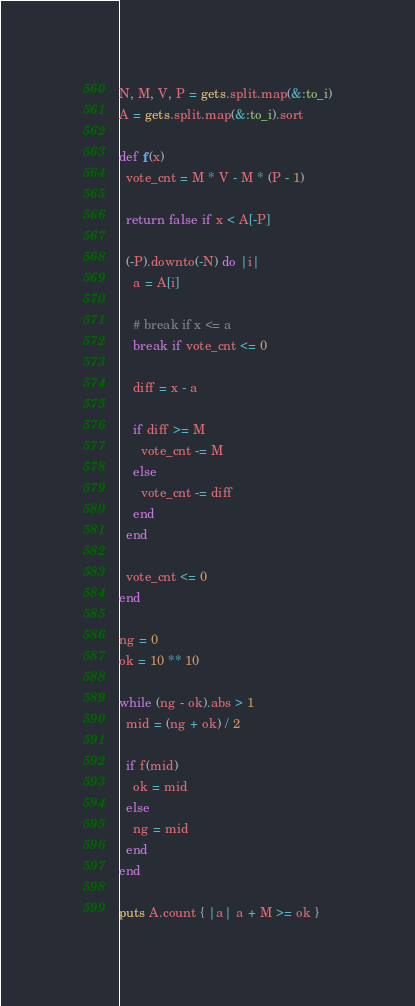<code> <loc_0><loc_0><loc_500><loc_500><_Ruby_>N, M, V, P = gets.split.map(&:to_i)
A = gets.split.map(&:to_i).sort

def f(x)
  vote_cnt = M * V - M * (P - 1)

  return false if x < A[-P]

  (-P).downto(-N) do |i|
    a = A[i]

    # break if x <= a
    break if vote_cnt <= 0

    diff = x - a

    if diff >= M
      vote_cnt -= M
    else
      vote_cnt -= diff
    end
  end

  vote_cnt <= 0
end

ng = 0
ok = 10 ** 10

while (ng - ok).abs > 1
  mid = (ng + ok) / 2

  if f(mid)
    ok = mid
  else
    ng = mid
  end
end

puts A.count { |a| a + M >= ok }

</code> 